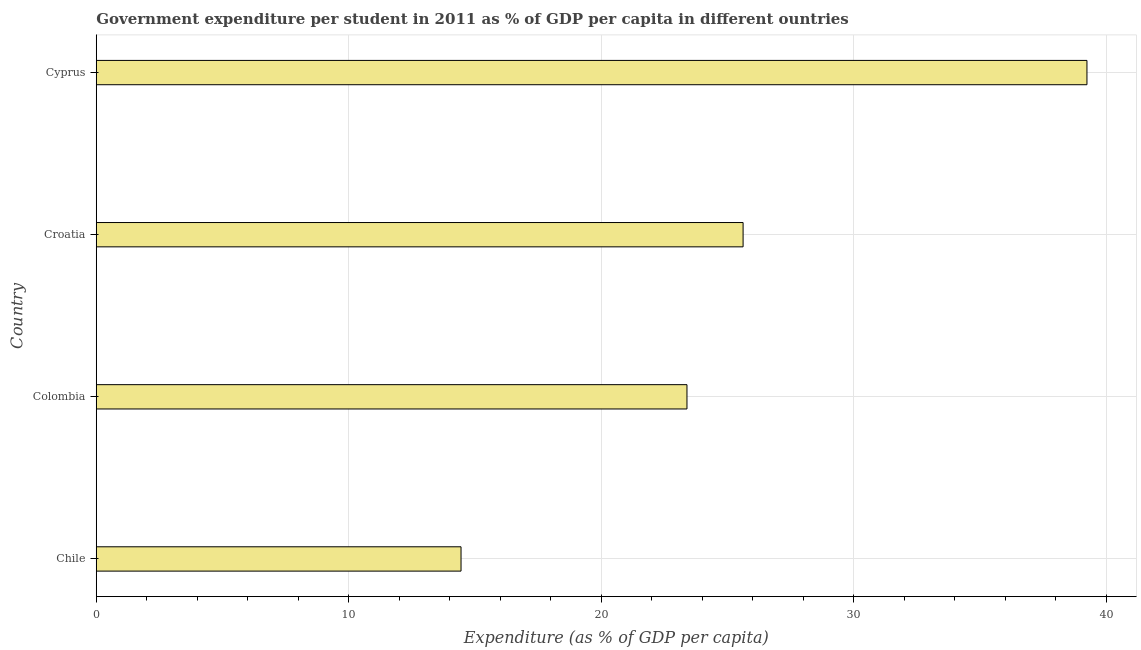Does the graph contain any zero values?
Your response must be concise. No. What is the title of the graph?
Your answer should be compact. Government expenditure per student in 2011 as % of GDP per capita in different ountries. What is the label or title of the X-axis?
Provide a short and direct response. Expenditure (as % of GDP per capita). What is the label or title of the Y-axis?
Provide a short and direct response. Country. What is the government expenditure per student in Croatia?
Your answer should be compact. 25.61. Across all countries, what is the maximum government expenditure per student?
Your answer should be very brief. 39.23. Across all countries, what is the minimum government expenditure per student?
Ensure brevity in your answer.  14.45. In which country was the government expenditure per student maximum?
Make the answer very short. Cyprus. In which country was the government expenditure per student minimum?
Keep it short and to the point. Chile. What is the sum of the government expenditure per student?
Provide a succinct answer. 102.68. What is the difference between the government expenditure per student in Chile and Cyprus?
Give a very brief answer. -24.79. What is the average government expenditure per student per country?
Offer a very short reply. 25.67. What is the median government expenditure per student?
Your answer should be compact. 24.5. What is the ratio of the government expenditure per student in Chile to that in Colombia?
Keep it short and to the point. 0.62. Is the government expenditure per student in Croatia less than that in Cyprus?
Provide a succinct answer. Yes. Is the difference between the government expenditure per student in Colombia and Croatia greater than the difference between any two countries?
Offer a terse response. No. What is the difference between the highest and the second highest government expenditure per student?
Offer a terse response. 13.62. What is the difference between the highest and the lowest government expenditure per student?
Provide a succinct answer. 24.79. What is the difference between two consecutive major ticks on the X-axis?
Make the answer very short. 10. Are the values on the major ticks of X-axis written in scientific E-notation?
Provide a short and direct response. No. What is the Expenditure (as % of GDP per capita) of Chile?
Offer a very short reply. 14.45. What is the Expenditure (as % of GDP per capita) in Colombia?
Ensure brevity in your answer.  23.39. What is the Expenditure (as % of GDP per capita) of Croatia?
Keep it short and to the point. 25.61. What is the Expenditure (as % of GDP per capita) in Cyprus?
Offer a terse response. 39.23. What is the difference between the Expenditure (as % of GDP per capita) in Chile and Colombia?
Provide a succinct answer. -8.95. What is the difference between the Expenditure (as % of GDP per capita) in Chile and Croatia?
Your answer should be very brief. -11.17. What is the difference between the Expenditure (as % of GDP per capita) in Chile and Cyprus?
Offer a very short reply. -24.79. What is the difference between the Expenditure (as % of GDP per capita) in Colombia and Croatia?
Provide a succinct answer. -2.22. What is the difference between the Expenditure (as % of GDP per capita) in Colombia and Cyprus?
Offer a very short reply. -15.84. What is the difference between the Expenditure (as % of GDP per capita) in Croatia and Cyprus?
Your answer should be compact. -13.62. What is the ratio of the Expenditure (as % of GDP per capita) in Chile to that in Colombia?
Offer a terse response. 0.62. What is the ratio of the Expenditure (as % of GDP per capita) in Chile to that in Croatia?
Keep it short and to the point. 0.56. What is the ratio of the Expenditure (as % of GDP per capita) in Chile to that in Cyprus?
Provide a succinct answer. 0.37. What is the ratio of the Expenditure (as % of GDP per capita) in Colombia to that in Croatia?
Your answer should be compact. 0.91. What is the ratio of the Expenditure (as % of GDP per capita) in Colombia to that in Cyprus?
Ensure brevity in your answer.  0.6. What is the ratio of the Expenditure (as % of GDP per capita) in Croatia to that in Cyprus?
Your answer should be very brief. 0.65. 